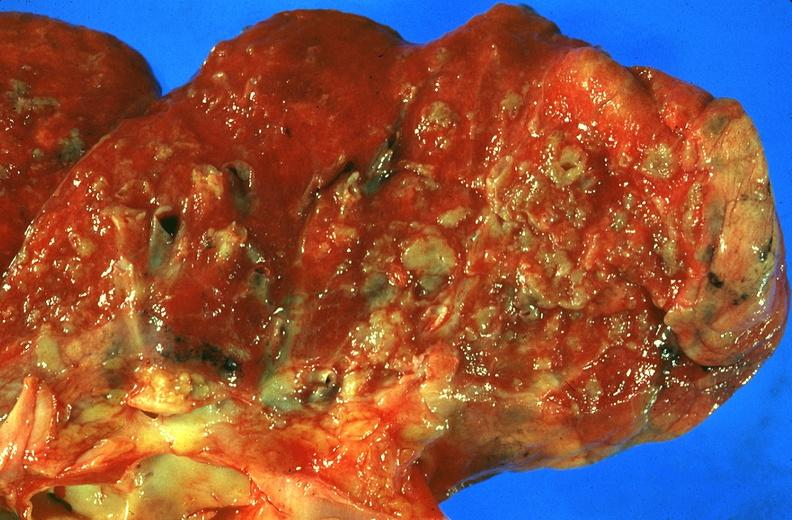s respiratory present?
Answer the question using a single word or phrase. Yes 